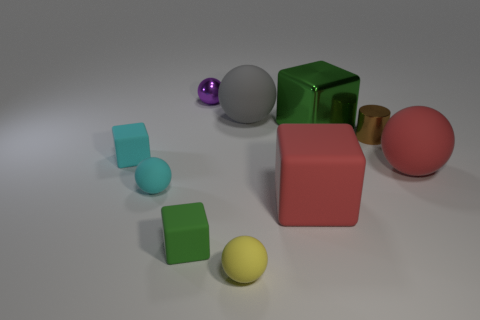What is the size of the green block that is to the right of the tiny purple ball on the left side of the tiny metal cylinder? The green block to the right of the tiny purple ball, itself situated on the left side of the tiny metal cylinder, is large compared to the surrounding objects, which include smaller blocks and balls. 